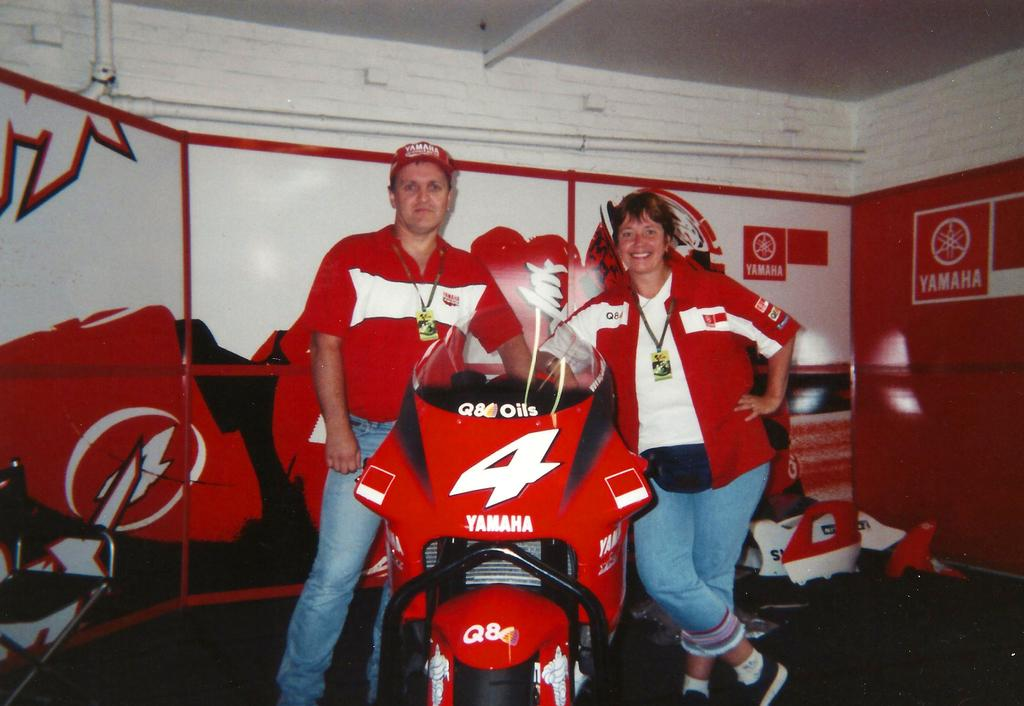<image>
Create a compact narrative representing the image presented. A man and woman are standing next to a red motorcycle that says Yamaha. 